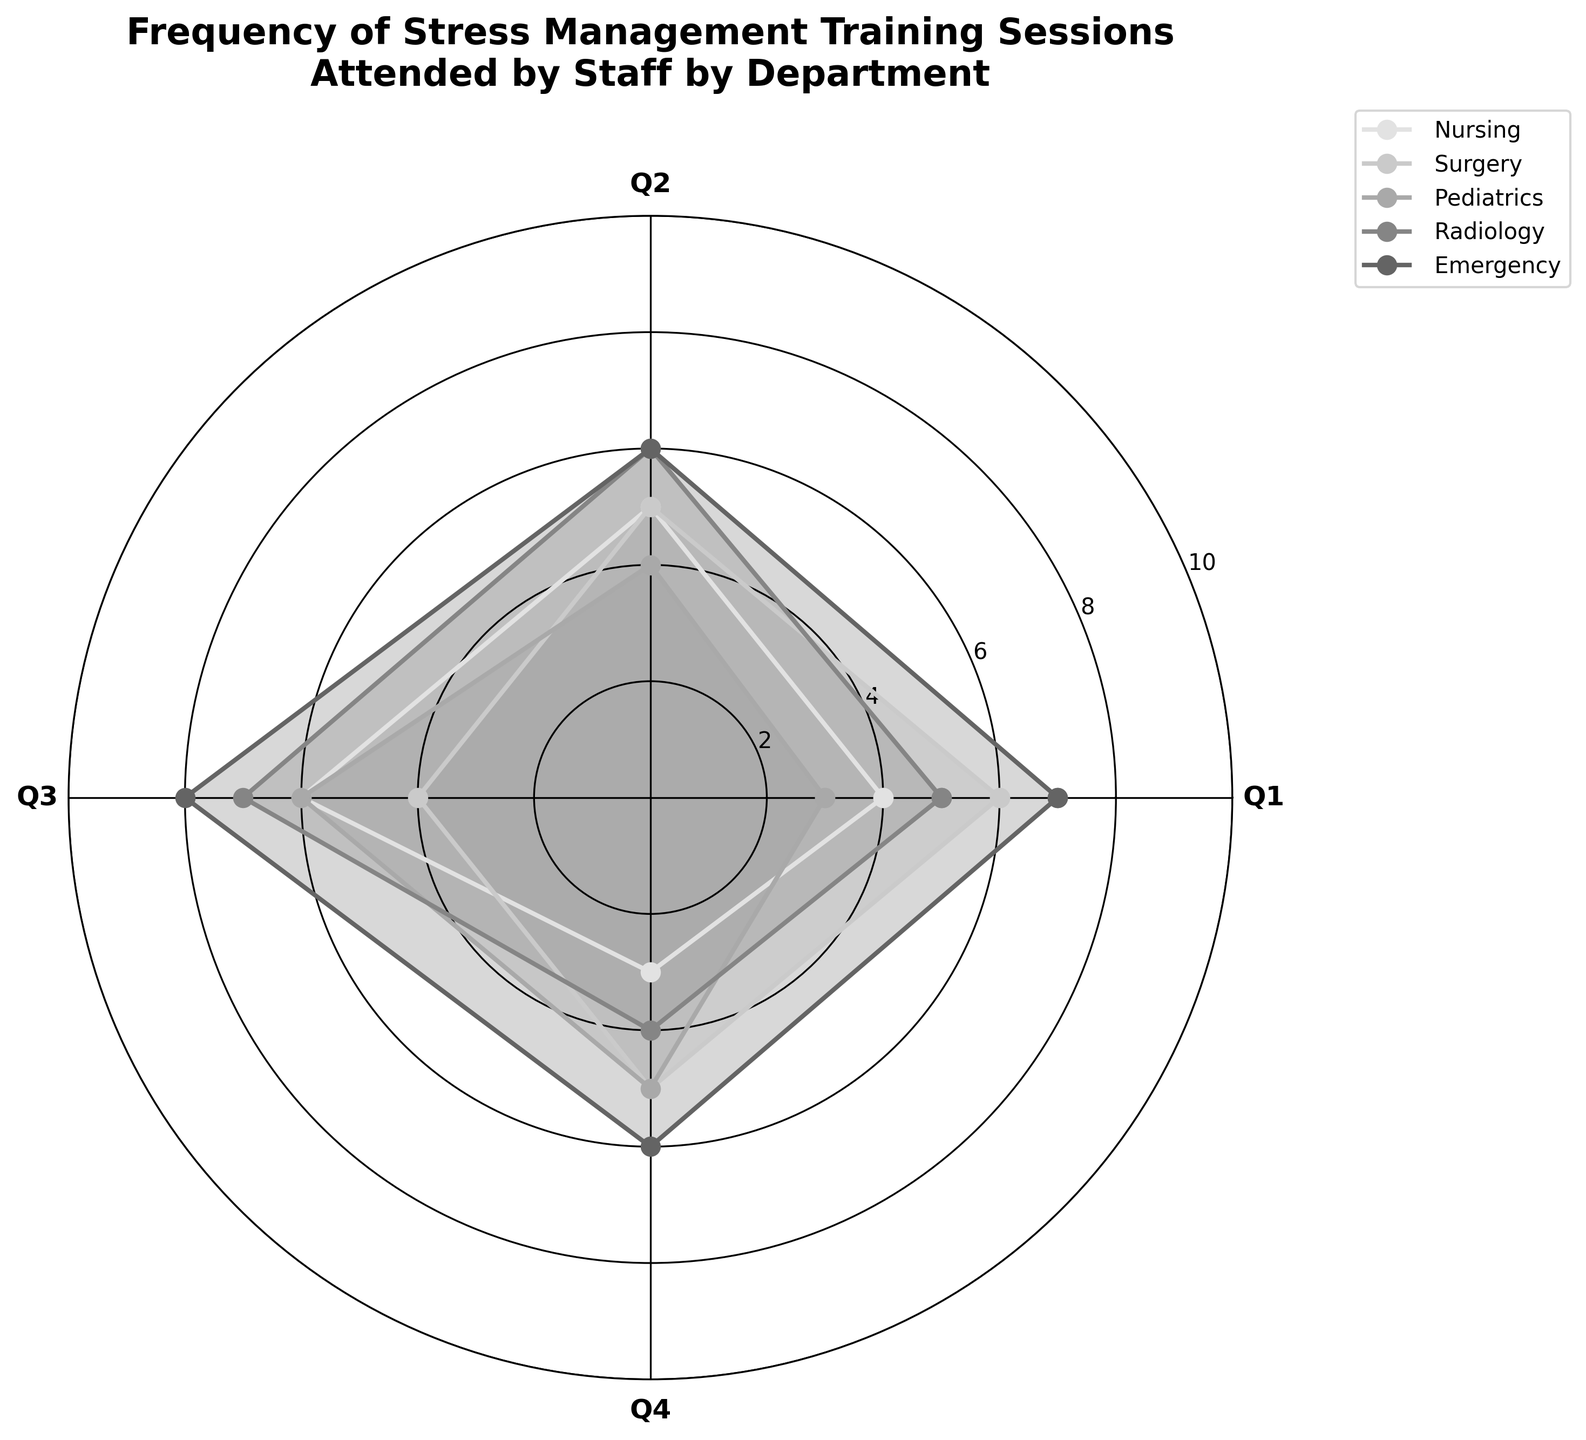What is the title of the figure? The title of the figure is displayed at the top of the chart. It reads "Frequency of Stress Management Training Sessions Attended by Staff by Department".
Answer: Frequency of Stress Management Training Sessions Attended by Staff by Department Which department participated in the most training sessions in Q1? Looking at the radial lines extending closest to the outer boundary, the Emergency department has the largest radial extension in Q1.
Answer: Emergency How many sessions did the Pediatrics department attend in Q3? Since each department's data is plotted with different radial extents, you can identify Pediatrics by its plotted data and locate Q3. The radial extent for Pediatrics in Q3 corresponds to 6.
Answer: 6 Compare the total number of sessions attended by the Nursing and Radiology departments. Which department attended fewer sessions? Summing the values for both: Nursing (4+5+6+3 = 18) and Radiology (5+6+7+4 = 22). The Nursing department has a lower total.
Answer: Nursing Which quarter had the highest total number of sessions across all departments? Adding sessions for Q1 (4+6+3+5+7 = 25), Q2 (5+5+4+6+6 = 26), Q3 (6+4+6+7+8 = 31), Q4 (3+5+5+4+6 = 23). Q3 has the highest total.
Answer: Q3 Which department displayed the most varying attendance across all quarters? Examination of the variability in radial extents, Emergency department shows a wide range from 7 (Q1) to 8 (Q3) and smaller values in other quarters.
Answer: Emergency What is the minimum number of sessions any department attended in any quarter? Looking at the shortest radial extents, the smallest value appears to be 3 sessions in Q4 by Nursing department.
Answer: 3 What is the average number of sessions attended by the Surgery department? Adding the Surgery department: 6+5+4+5 = 20, then dividing by 4 quarters: 20 / 4 = 5.
Answer: 5 Compare the difference in attendance between the Pediatrics and Emergency departments for Q3. From Q3 values, Pediatrics attended 6 sessions while Emergency attended 8. The difference is 8 - 6 = 2.
Answer: 2 Which department had a consistent number of sessions attended across all quarters? Observing the radial extents and noting patterns, Surgery shows values of 6, 5, 4, 5, which are relatively consistent compared to others.
Answer: Surgery 